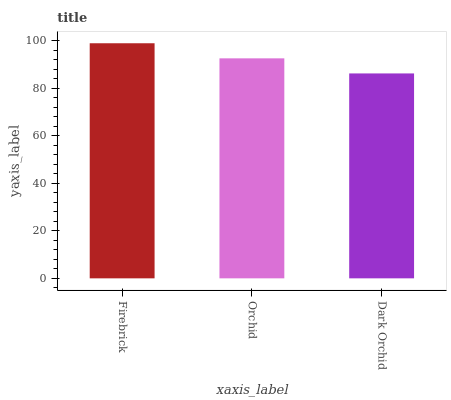Is Orchid the minimum?
Answer yes or no. No. Is Orchid the maximum?
Answer yes or no. No. Is Firebrick greater than Orchid?
Answer yes or no. Yes. Is Orchid less than Firebrick?
Answer yes or no. Yes. Is Orchid greater than Firebrick?
Answer yes or no. No. Is Firebrick less than Orchid?
Answer yes or no. No. Is Orchid the high median?
Answer yes or no. Yes. Is Orchid the low median?
Answer yes or no. Yes. Is Firebrick the high median?
Answer yes or no. No. Is Firebrick the low median?
Answer yes or no. No. 